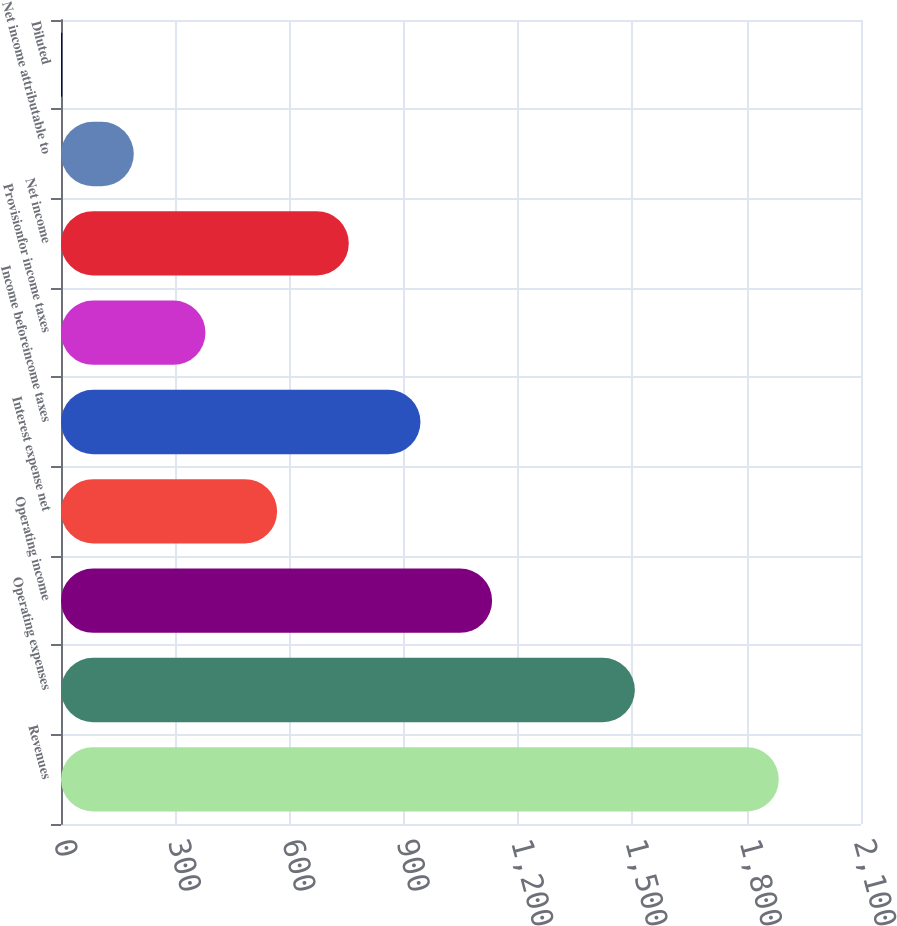Convert chart. <chart><loc_0><loc_0><loc_500><loc_500><bar_chart><fcel>Revenues<fcel>Operating expenses<fcel>Operating income<fcel>Interest expense net<fcel>Income beforeincome taxes<fcel>Provisionfor income taxes<fcel>Net income<fcel>Net income attributable to<fcel>Diluted<nl><fcel>1884.2<fcel>1506.4<fcel>1131.7<fcel>567.32<fcel>943.58<fcel>379.19<fcel>755.45<fcel>191.07<fcel>2.95<nl></chart> 